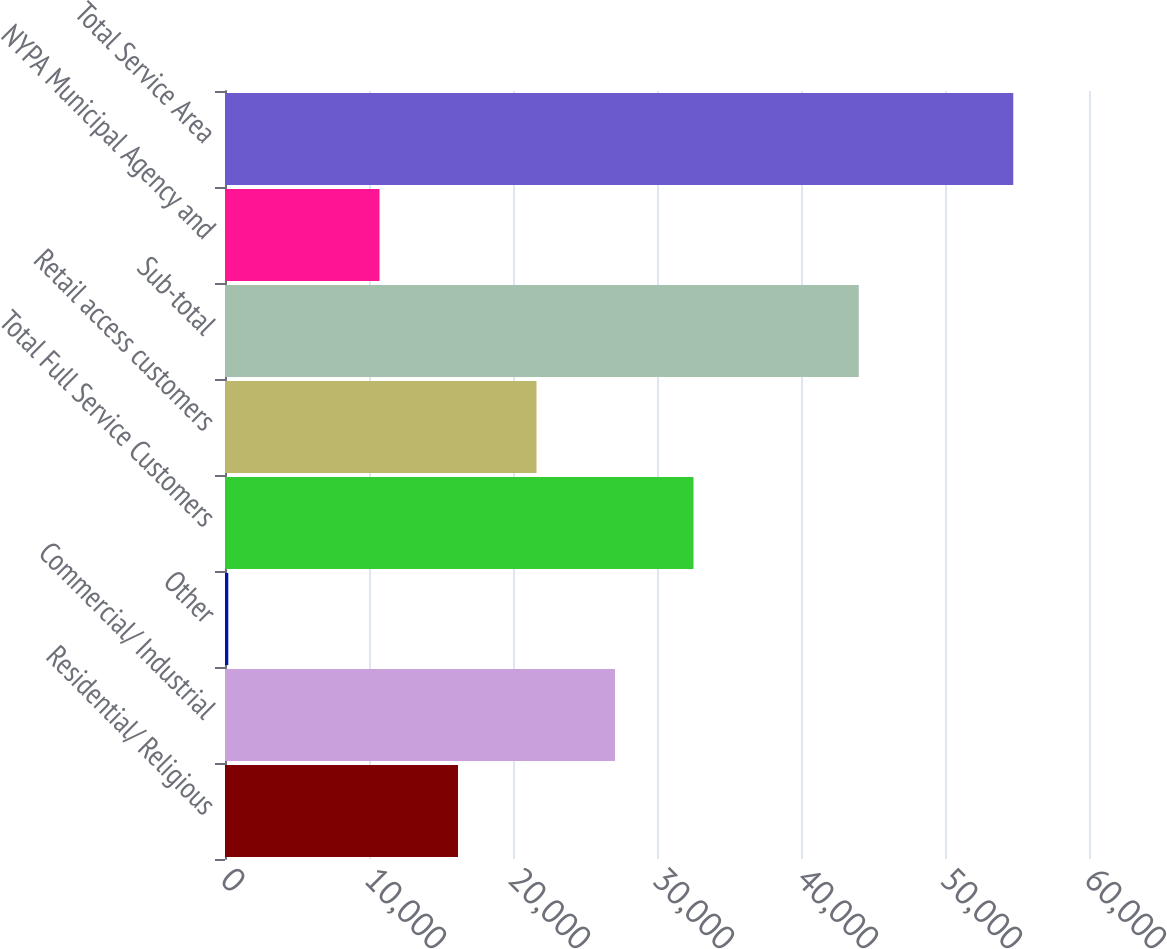Convert chart. <chart><loc_0><loc_0><loc_500><loc_500><bar_chart><fcel>Residential/ Religious<fcel>Commercial/ Industrial<fcel>Other<fcel>Total Full Service Customers<fcel>Retail access customers<fcel>Sub-total<fcel>NYPA Municipal Agency and<fcel>Total Service Area<nl><fcel>16181.2<fcel>27083.6<fcel>229<fcel>32534.8<fcel>21632.4<fcel>44011<fcel>10730<fcel>54741<nl></chart> 